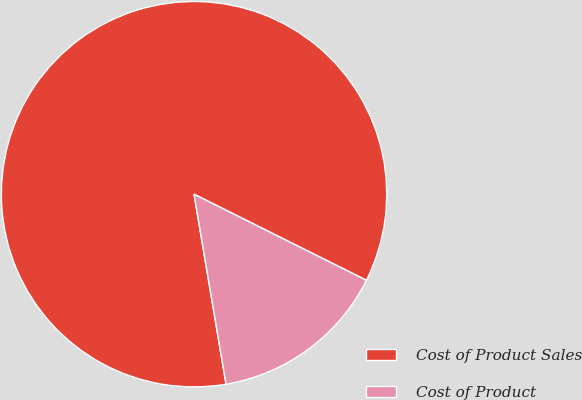<chart> <loc_0><loc_0><loc_500><loc_500><pie_chart><fcel>Cost of Product Sales<fcel>Cost of Product<nl><fcel>85.03%<fcel>14.97%<nl></chart> 